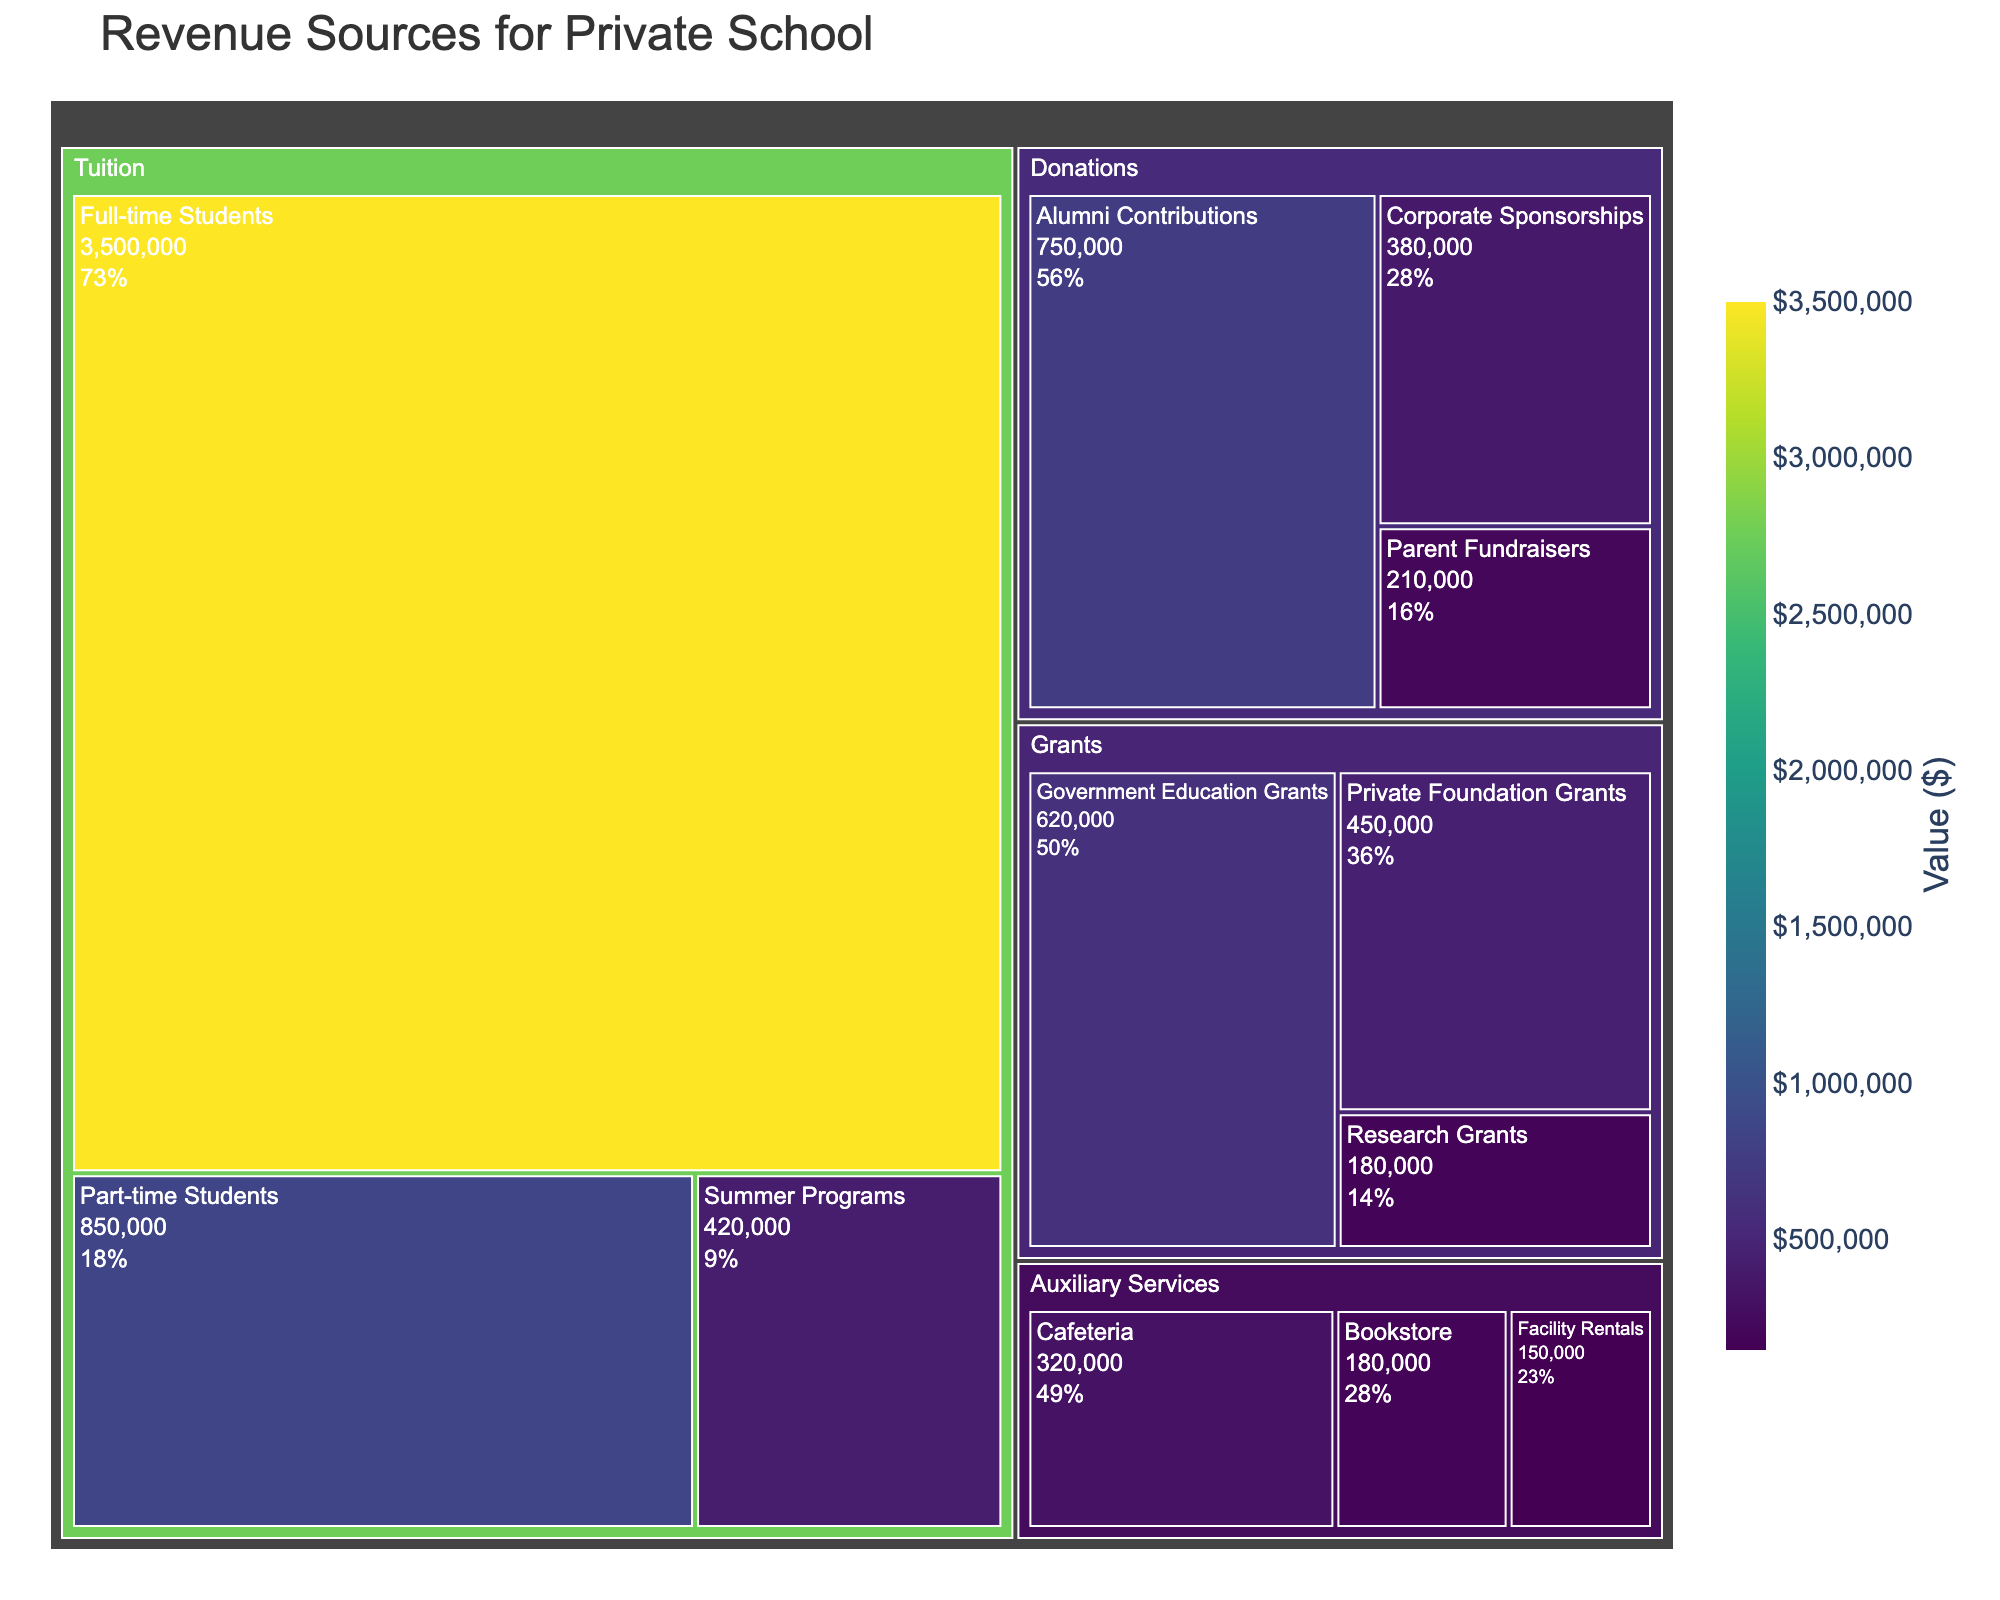What is the total revenue generated from Tuition? To find the total revenue generated from Tuition, we sum the values of Full-time Students, Part-time Students, and Summer Programs: 3,500,000 + 850,000 + 420,000.
Answer: $4,770,000 Which subcategory under Donations has the highest revenue? By looking at the figure, Alumni Contributions under Donations has the highest revenue at $750,000.
Answer: Alumni Contributions How much more revenue do Full-time Students generate compared to Part-time Students? The revenue from Full-time Students is $3,500,000 and from Part-time Students is $850,000. The difference is calculated by subtracting the revenue of Part-time Students from that of Full-time Students: 3,500,000 - 850,000.
Answer: $2,650,000 What percentage of the total Donation revenue comes from Corporate Sponsorships? First, calculate the total Donations revenue by summing Alumni Contributions, Corporate Sponsorships, and Parent Fundraisers: 750,000 + 380,000 + 210,000 = 1,340,000. Then, divide the revenue of Corporate Sponsorships by the total Donations revenue and multiply by 100: (380,000 / 1,340,000) * 100.
Answer: 28.36% Which category contributes the least to the overall revenue, and what is its total value? By summing the values in each category, we find that Auxiliary Services is the least, with Cafeteria, Bookstore, and Facility Rentals totaling: 320,000 + 180,000 + 150,000 = 650,000.
Answer: Auxiliary Services, $650,000 What is the combined revenue from Grants and Auxiliary Services? Summing the totals from Grants (620,000 + 450,000 + 180,000) and Auxiliary Services (320,000 + 180,000 + 150,000): 1,250,000 (Grants) + 650,000 (Auxiliary Services).
Answer: $1,900,000 Compare the revenue generated by Full-time Students to the total revenue from Donations. Which is higher and by how much? The revenue from Full-time Students is $3,500,000. The total revenue from Donations is the sum of Alumni Contributions, Corporate Sponsorships, and Parent Fundraisers: 750,000 + 380,000 + 210,000 = 1,340,000. Comparing the two: 3,500,000 - 1,340,000.
Answer: Full-time Students by $2,160,000 